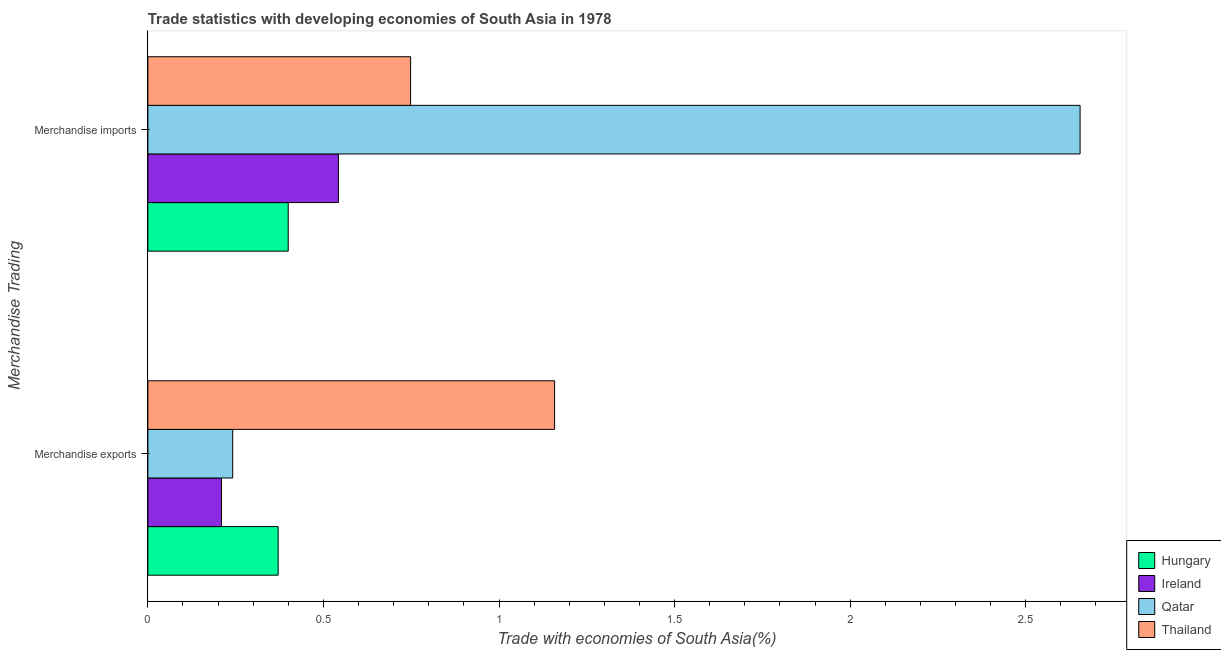How many different coloured bars are there?
Provide a short and direct response. 4. Are the number of bars on each tick of the Y-axis equal?
Offer a very short reply. Yes. How many bars are there on the 1st tick from the top?
Your answer should be very brief. 4. How many bars are there on the 2nd tick from the bottom?
Keep it short and to the point. 4. What is the merchandise exports in Qatar?
Ensure brevity in your answer.  0.24. Across all countries, what is the maximum merchandise exports?
Your answer should be very brief. 1.16. Across all countries, what is the minimum merchandise exports?
Your answer should be compact. 0.21. In which country was the merchandise imports maximum?
Make the answer very short. Qatar. In which country was the merchandise imports minimum?
Your answer should be compact. Hungary. What is the total merchandise exports in the graph?
Your response must be concise. 1.98. What is the difference between the merchandise exports in Hungary and that in Ireland?
Your answer should be very brief. 0.16. What is the difference between the merchandise exports in Qatar and the merchandise imports in Hungary?
Offer a very short reply. -0.16. What is the average merchandise exports per country?
Offer a very short reply. 0.5. What is the difference between the merchandise imports and merchandise exports in Ireland?
Offer a very short reply. 0.33. What is the ratio of the merchandise exports in Qatar to that in Ireland?
Your answer should be very brief. 1.15. In how many countries, is the merchandise imports greater than the average merchandise imports taken over all countries?
Your answer should be very brief. 1. What does the 2nd bar from the top in Merchandise exports represents?
Keep it short and to the point. Qatar. What does the 4th bar from the bottom in Merchandise exports represents?
Offer a terse response. Thailand. Are all the bars in the graph horizontal?
Ensure brevity in your answer.  Yes. How many countries are there in the graph?
Offer a very short reply. 4. What is the difference between two consecutive major ticks on the X-axis?
Keep it short and to the point. 0.5. Are the values on the major ticks of X-axis written in scientific E-notation?
Provide a succinct answer. No. Does the graph contain any zero values?
Offer a terse response. No. How many legend labels are there?
Give a very brief answer. 4. What is the title of the graph?
Provide a short and direct response. Trade statistics with developing economies of South Asia in 1978. What is the label or title of the X-axis?
Your response must be concise. Trade with economies of South Asia(%). What is the label or title of the Y-axis?
Give a very brief answer. Merchandise Trading. What is the Trade with economies of South Asia(%) in Hungary in Merchandise exports?
Make the answer very short. 0.37. What is the Trade with economies of South Asia(%) in Ireland in Merchandise exports?
Provide a succinct answer. 0.21. What is the Trade with economies of South Asia(%) of Qatar in Merchandise exports?
Give a very brief answer. 0.24. What is the Trade with economies of South Asia(%) in Thailand in Merchandise exports?
Offer a terse response. 1.16. What is the Trade with economies of South Asia(%) in Hungary in Merchandise imports?
Your answer should be very brief. 0.4. What is the Trade with economies of South Asia(%) of Ireland in Merchandise imports?
Your answer should be very brief. 0.54. What is the Trade with economies of South Asia(%) of Qatar in Merchandise imports?
Ensure brevity in your answer.  2.65. What is the Trade with economies of South Asia(%) of Thailand in Merchandise imports?
Offer a very short reply. 0.75. Across all Merchandise Trading, what is the maximum Trade with economies of South Asia(%) of Hungary?
Your answer should be compact. 0.4. Across all Merchandise Trading, what is the maximum Trade with economies of South Asia(%) in Ireland?
Make the answer very short. 0.54. Across all Merchandise Trading, what is the maximum Trade with economies of South Asia(%) in Qatar?
Make the answer very short. 2.65. Across all Merchandise Trading, what is the maximum Trade with economies of South Asia(%) in Thailand?
Give a very brief answer. 1.16. Across all Merchandise Trading, what is the minimum Trade with economies of South Asia(%) of Hungary?
Your answer should be compact. 0.37. Across all Merchandise Trading, what is the minimum Trade with economies of South Asia(%) of Ireland?
Make the answer very short. 0.21. Across all Merchandise Trading, what is the minimum Trade with economies of South Asia(%) of Qatar?
Keep it short and to the point. 0.24. Across all Merchandise Trading, what is the minimum Trade with economies of South Asia(%) in Thailand?
Provide a short and direct response. 0.75. What is the total Trade with economies of South Asia(%) in Hungary in the graph?
Keep it short and to the point. 0.77. What is the total Trade with economies of South Asia(%) in Ireland in the graph?
Make the answer very short. 0.75. What is the total Trade with economies of South Asia(%) in Qatar in the graph?
Offer a very short reply. 2.9. What is the total Trade with economies of South Asia(%) of Thailand in the graph?
Make the answer very short. 1.91. What is the difference between the Trade with economies of South Asia(%) in Hungary in Merchandise exports and that in Merchandise imports?
Offer a very short reply. -0.03. What is the difference between the Trade with economies of South Asia(%) of Ireland in Merchandise exports and that in Merchandise imports?
Ensure brevity in your answer.  -0.33. What is the difference between the Trade with economies of South Asia(%) in Qatar in Merchandise exports and that in Merchandise imports?
Make the answer very short. -2.41. What is the difference between the Trade with economies of South Asia(%) of Thailand in Merchandise exports and that in Merchandise imports?
Provide a short and direct response. 0.41. What is the difference between the Trade with economies of South Asia(%) of Hungary in Merchandise exports and the Trade with economies of South Asia(%) of Ireland in Merchandise imports?
Offer a very short reply. -0.17. What is the difference between the Trade with economies of South Asia(%) in Hungary in Merchandise exports and the Trade with economies of South Asia(%) in Qatar in Merchandise imports?
Your answer should be very brief. -2.28. What is the difference between the Trade with economies of South Asia(%) in Hungary in Merchandise exports and the Trade with economies of South Asia(%) in Thailand in Merchandise imports?
Your answer should be compact. -0.38. What is the difference between the Trade with economies of South Asia(%) in Ireland in Merchandise exports and the Trade with economies of South Asia(%) in Qatar in Merchandise imports?
Give a very brief answer. -2.45. What is the difference between the Trade with economies of South Asia(%) of Ireland in Merchandise exports and the Trade with economies of South Asia(%) of Thailand in Merchandise imports?
Ensure brevity in your answer.  -0.54. What is the difference between the Trade with economies of South Asia(%) in Qatar in Merchandise exports and the Trade with economies of South Asia(%) in Thailand in Merchandise imports?
Provide a succinct answer. -0.51. What is the average Trade with economies of South Asia(%) of Hungary per Merchandise Trading?
Ensure brevity in your answer.  0.39. What is the average Trade with economies of South Asia(%) of Ireland per Merchandise Trading?
Provide a succinct answer. 0.38. What is the average Trade with economies of South Asia(%) of Qatar per Merchandise Trading?
Your response must be concise. 1.45. What is the average Trade with economies of South Asia(%) in Thailand per Merchandise Trading?
Keep it short and to the point. 0.95. What is the difference between the Trade with economies of South Asia(%) in Hungary and Trade with economies of South Asia(%) in Ireland in Merchandise exports?
Your answer should be very brief. 0.16. What is the difference between the Trade with economies of South Asia(%) in Hungary and Trade with economies of South Asia(%) in Qatar in Merchandise exports?
Provide a succinct answer. 0.13. What is the difference between the Trade with economies of South Asia(%) in Hungary and Trade with economies of South Asia(%) in Thailand in Merchandise exports?
Provide a succinct answer. -0.79. What is the difference between the Trade with economies of South Asia(%) of Ireland and Trade with economies of South Asia(%) of Qatar in Merchandise exports?
Your response must be concise. -0.03. What is the difference between the Trade with economies of South Asia(%) in Ireland and Trade with economies of South Asia(%) in Thailand in Merchandise exports?
Ensure brevity in your answer.  -0.95. What is the difference between the Trade with economies of South Asia(%) in Qatar and Trade with economies of South Asia(%) in Thailand in Merchandise exports?
Offer a terse response. -0.92. What is the difference between the Trade with economies of South Asia(%) in Hungary and Trade with economies of South Asia(%) in Ireland in Merchandise imports?
Offer a very short reply. -0.14. What is the difference between the Trade with economies of South Asia(%) of Hungary and Trade with economies of South Asia(%) of Qatar in Merchandise imports?
Provide a succinct answer. -2.26. What is the difference between the Trade with economies of South Asia(%) of Hungary and Trade with economies of South Asia(%) of Thailand in Merchandise imports?
Your response must be concise. -0.35. What is the difference between the Trade with economies of South Asia(%) of Ireland and Trade with economies of South Asia(%) of Qatar in Merchandise imports?
Your answer should be compact. -2.11. What is the difference between the Trade with economies of South Asia(%) of Ireland and Trade with economies of South Asia(%) of Thailand in Merchandise imports?
Give a very brief answer. -0.21. What is the difference between the Trade with economies of South Asia(%) of Qatar and Trade with economies of South Asia(%) of Thailand in Merchandise imports?
Your answer should be very brief. 1.91. What is the ratio of the Trade with economies of South Asia(%) in Hungary in Merchandise exports to that in Merchandise imports?
Offer a terse response. 0.93. What is the ratio of the Trade with economies of South Asia(%) in Ireland in Merchandise exports to that in Merchandise imports?
Offer a terse response. 0.39. What is the ratio of the Trade with economies of South Asia(%) in Qatar in Merchandise exports to that in Merchandise imports?
Your answer should be compact. 0.09. What is the ratio of the Trade with economies of South Asia(%) of Thailand in Merchandise exports to that in Merchandise imports?
Your response must be concise. 1.55. What is the difference between the highest and the second highest Trade with economies of South Asia(%) of Hungary?
Your answer should be very brief. 0.03. What is the difference between the highest and the second highest Trade with economies of South Asia(%) of Ireland?
Provide a succinct answer. 0.33. What is the difference between the highest and the second highest Trade with economies of South Asia(%) of Qatar?
Offer a very short reply. 2.41. What is the difference between the highest and the second highest Trade with economies of South Asia(%) in Thailand?
Ensure brevity in your answer.  0.41. What is the difference between the highest and the lowest Trade with economies of South Asia(%) in Hungary?
Make the answer very short. 0.03. What is the difference between the highest and the lowest Trade with economies of South Asia(%) of Ireland?
Your answer should be very brief. 0.33. What is the difference between the highest and the lowest Trade with economies of South Asia(%) in Qatar?
Your response must be concise. 2.41. What is the difference between the highest and the lowest Trade with economies of South Asia(%) in Thailand?
Make the answer very short. 0.41. 